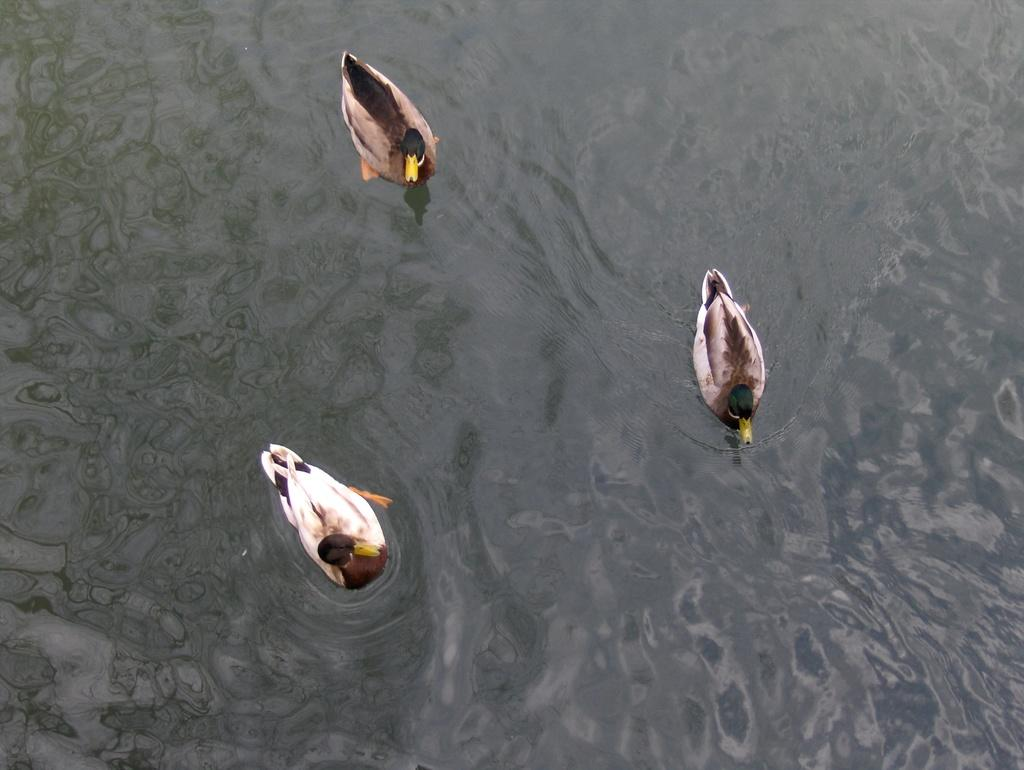What is the primary element in the image? The image contains water. What type of animals can be seen in the water? There are ducks in the water. What type of frame is around the map in the image? There is no map or frame present in the image; it features water with ducks. 